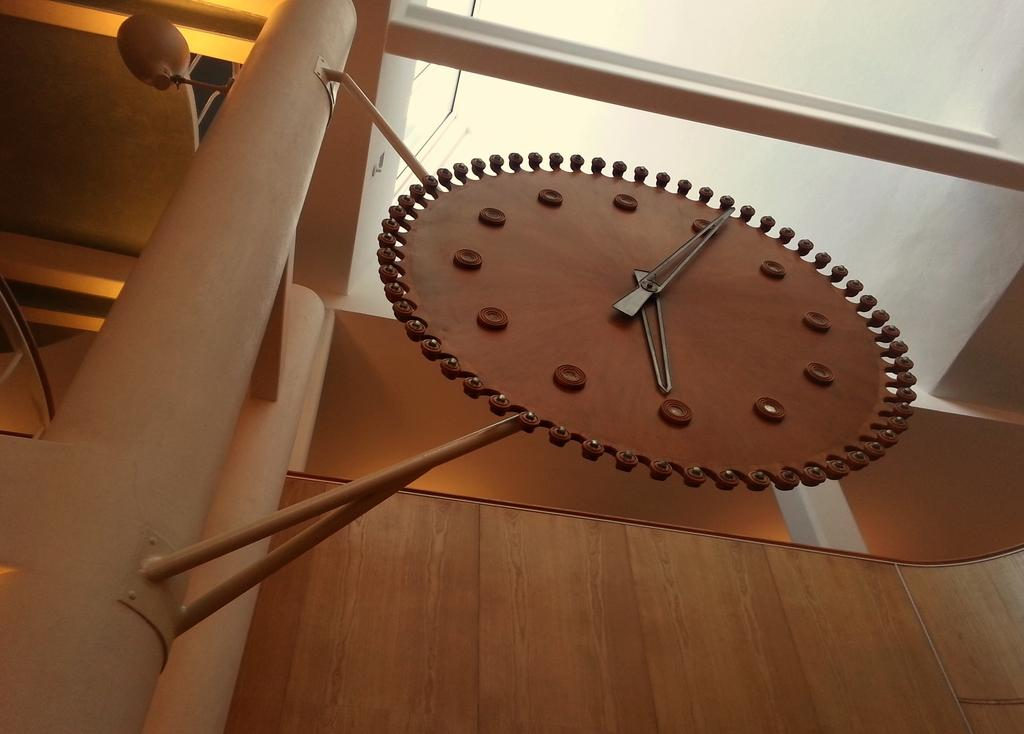What is the main object in the center of the image? There is a clock in the center of the image. How is the clock positioned in the image? The clock is placed on poles. What can be seen in the background of the image? There are lights, a window, and a wall visible in the background. What type of country is depicted in the image? There is no country depicted in the image; it features a clock placed on poles with a background that includes lights, a window, and a wall. How many lamps are visible in the image? There are no lamps visible in the image. 